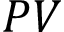Convert formula to latex. <formula><loc_0><loc_0><loc_500><loc_500>P V</formula> 